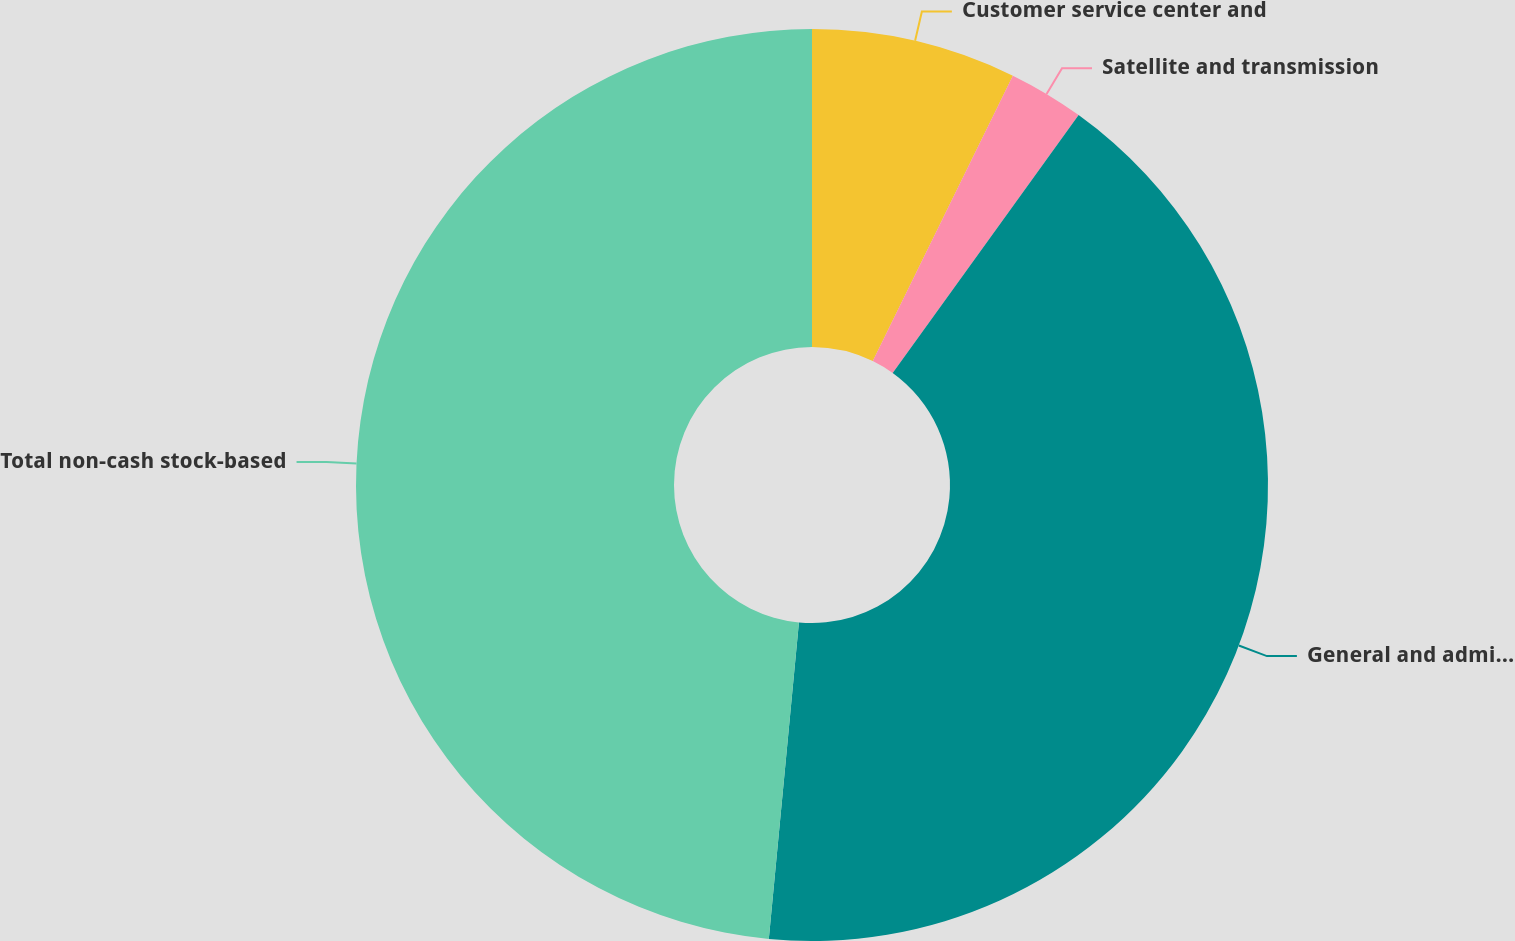Convert chart to OTSL. <chart><loc_0><loc_0><loc_500><loc_500><pie_chart><fcel>Customer service center and<fcel>Satellite and transmission<fcel>General and administrative<fcel>Total non-cash stock-based<nl><fcel>7.26%<fcel>2.68%<fcel>41.57%<fcel>48.49%<nl></chart> 